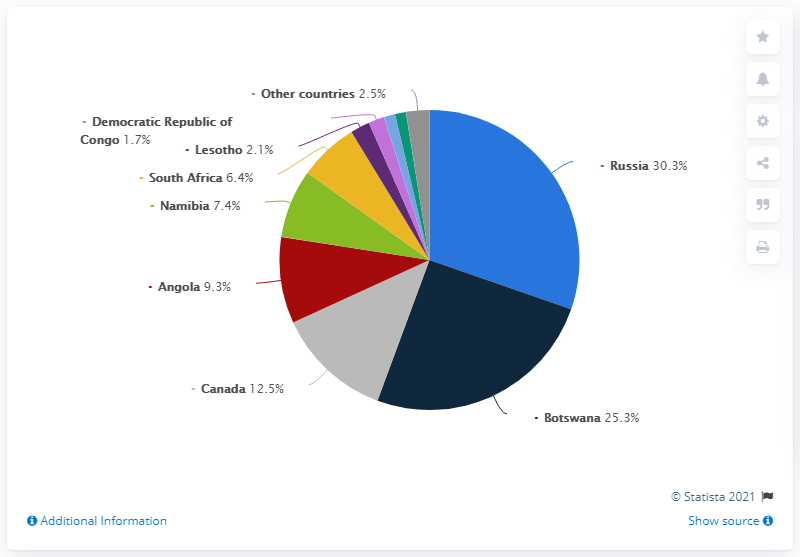Draw attention to some important aspects in this diagram. The sum of the two highest values is 55.6. In 2019, Russia accounted for 30.3% of the total value of diamonds produced worldwide. The pie chart represents 8 different countries, except for the category of "other countries". In 2019, Russia was the world's largest producer of rough diamonds. 